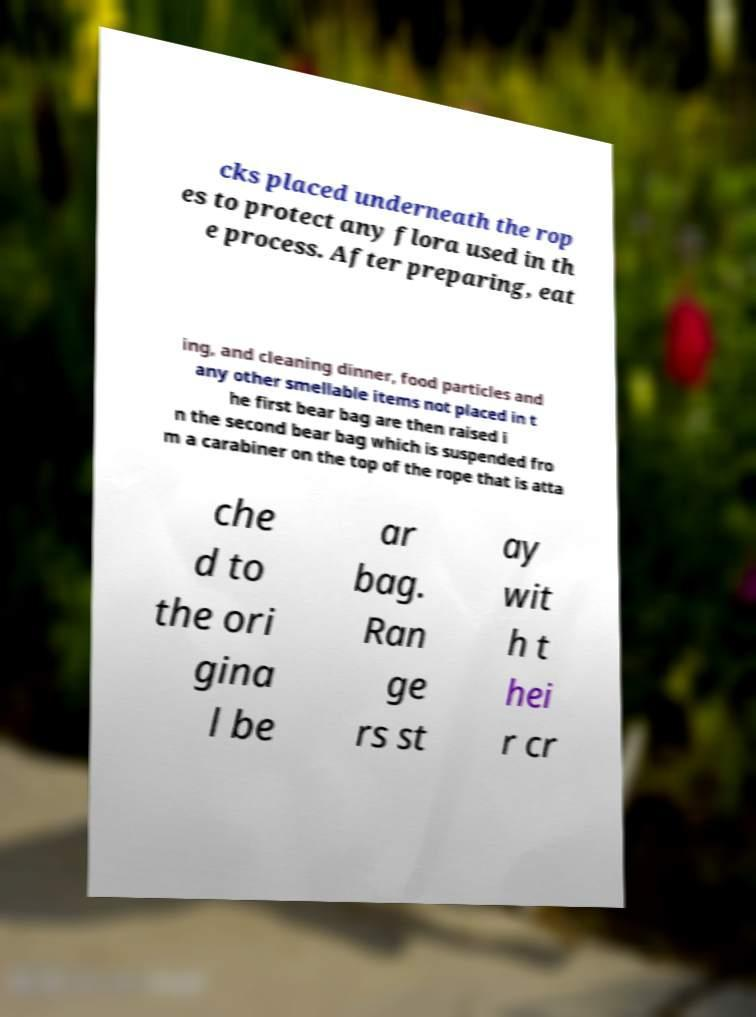Could you extract and type out the text from this image? cks placed underneath the rop es to protect any flora used in th e process. After preparing, eat ing, and cleaning dinner, food particles and any other smellable items not placed in t he first bear bag are then raised i n the second bear bag which is suspended fro m a carabiner on the top of the rope that is atta che d to the ori gina l be ar bag. Ran ge rs st ay wit h t hei r cr 